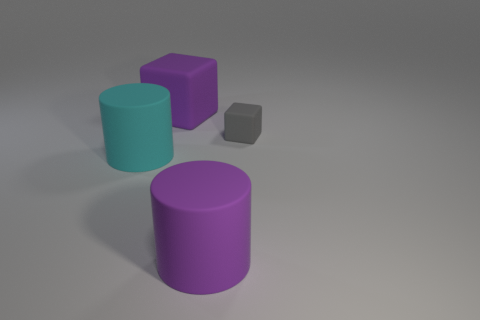Subtract all gray cubes. How many cubes are left? 1 Add 4 large purple cubes. How many objects exist? 8 Subtract all big blocks. Subtract all big blocks. How many objects are left? 2 Add 2 large rubber cubes. How many large rubber cubes are left? 3 Add 1 cyan metallic balls. How many cyan metallic balls exist? 1 Subtract 0 cyan cubes. How many objects are left? 4 Subtract 1 cubes. How many cubes are left? 1 Subtract all yellow cylinders. Subtract all purple balls. How many cylinders are left? 2 Subtract all gray cylinders. How many gray blocks are left? 1 